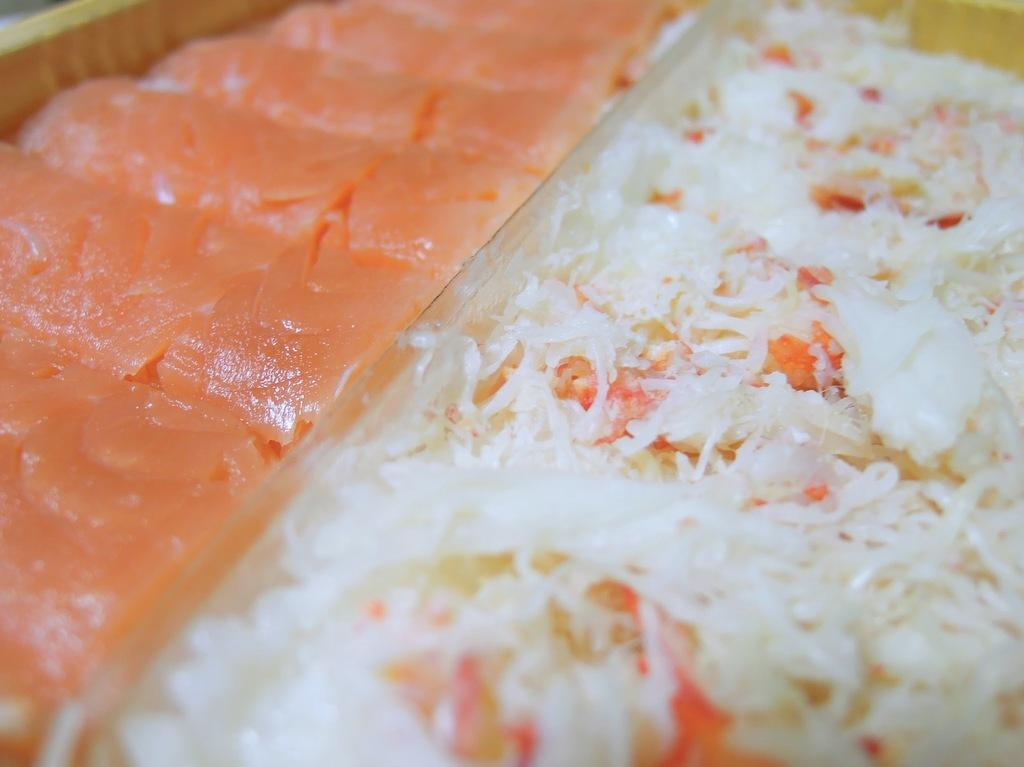What type of food can be seen in the image? There are pieces of salmon fish and porridge in the image. Can you describe the setting where the food is located? The image may have been taken in a restaurant. What type of battle is taking place in the image? There is no battle present in the image; it features pieces of salmon fish and porridge. What town is visible in the image? There is no town visible in the image; it may have been taken in a restaurant. 